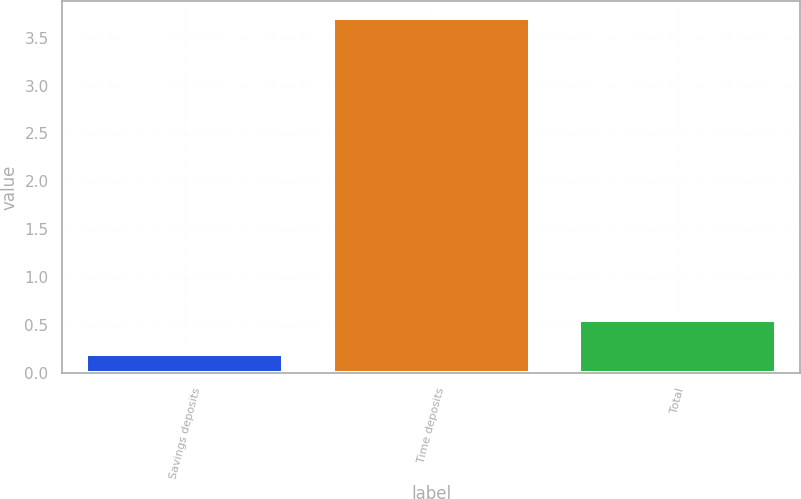Convert chart. <chart><loc_0><loc_0><loc_500><loc_500><bar_chart><fcel>Savings deposits<fcel>Time deposits<fcel>Total<nl><fcel>0.2<fcel>3.7<fcel>0.55<nl></chart> 